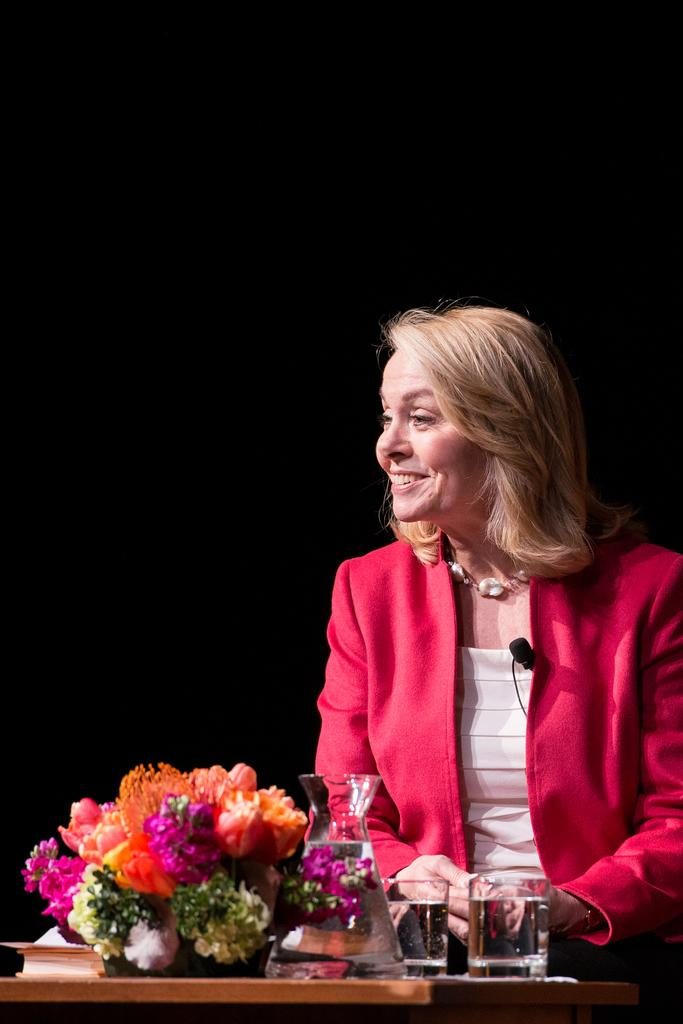What is the appearance of the woman in the image? There is a beautiful woman in the image. What is the woman's expression in the image? The woman is smiling in the image. What is the woman wearing in the image? The woman is wearing a red coat in the image. What objects can be seen on the table in the image? There are water glasses on a table in the image. What type of decoration is present in the image? There is a bouquet of flowers in the image. What type of juice is the woman drinking in the image? There is no juice present in the image; the woman is not drinking anything. How does the woman express her feelings towards the flowers in the image? The woman's feelings towards the flowers are not explicitly stated in the image, but her smile might suggest that she appreciates them. 